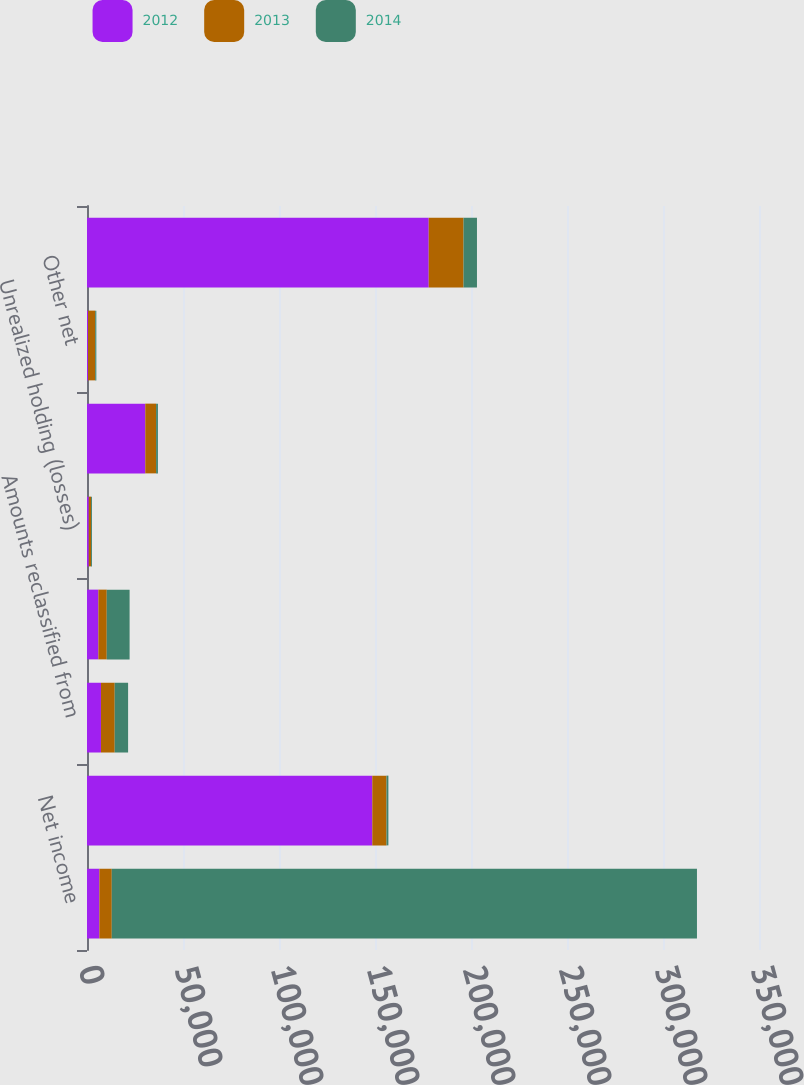<chart> <loc_0><loc_0><loc_500><loc_500><stacked_bar_chart><ecel><fcel>Net income<fcel>Foreign currency translation<fcel>Amounts reclassified from<fcel>Unrealized (losses) gains on<fcel>Unrealized holding (losses)<fcel>Pension liability adjustments<fcel>Other net<fcel>Total other comprehensive<nl><fcel>2012<fcel>6452<fcel>148589<fcel>7279<fcel>5927<fcel>941<fcel>30355<fcel>549<fcel>177984<nl><fcel>2013<fcel>6452<fcel>7390<fcel>7151<fcel>4361<fcel>1151<fcel>5638<fcel>3720<fcel>18135<nl><fcel>2014<fcel>304787<fcel>997<fcel>6977<fcel>11901<fcel>475<fcel>947<fcel>598<fcel>6991<nl></chart> 